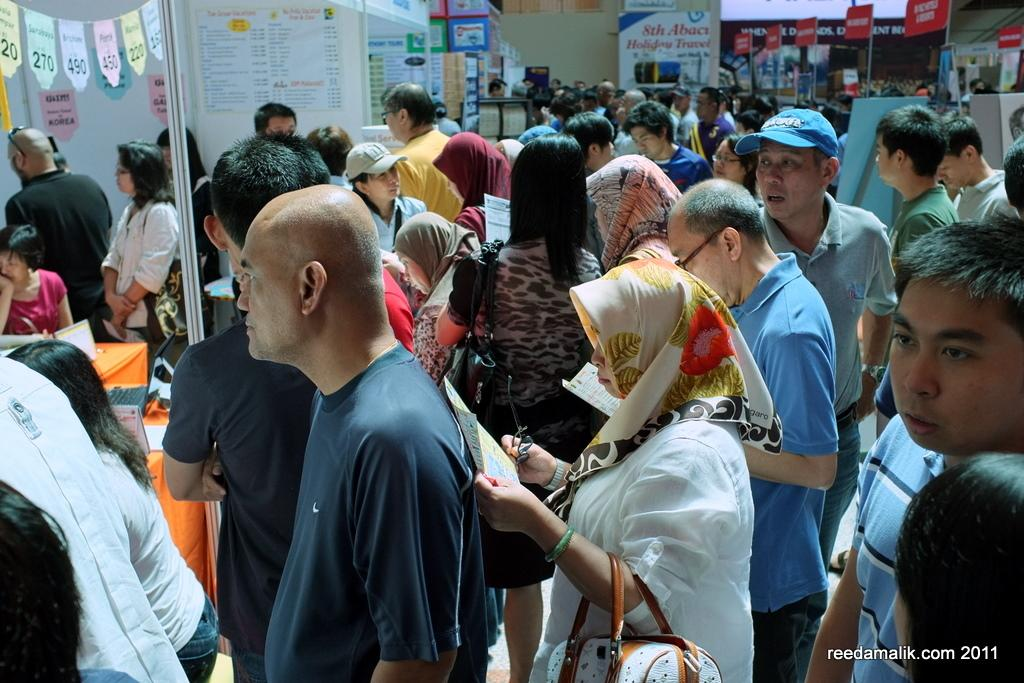Who or what can be seen in the image? There are people in the image. What type of structures are present in the image? There are stalls, boards, and a pole in the image. What type of advertising materials are visible in the image? There are hoardings and posters in the image. What else can be seen in the image besides people and structures? There are objects in the image. What type of beam is being distributed in the image? There is no beam being distributed in the image; the provided facts do not mention any beams. 